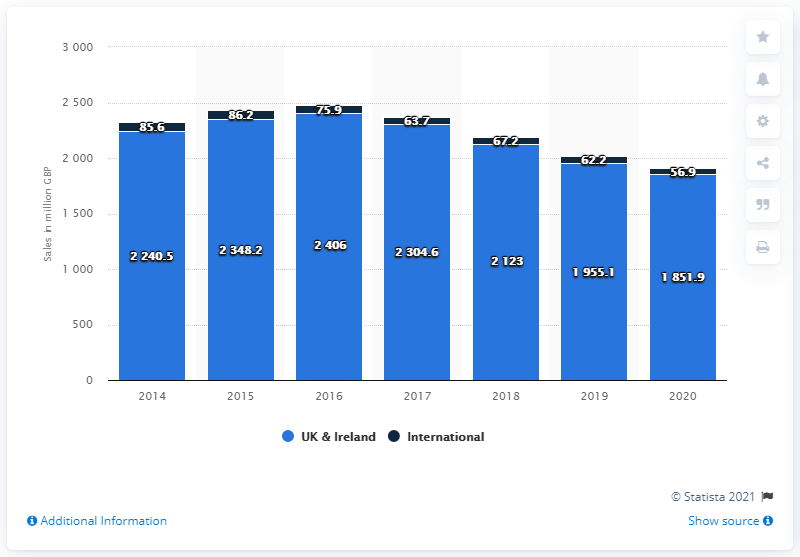What trend can we observe in Next plc's UK and Ireland sales over the past six years? The image shows a bar chart illustrating Next plc's UK and Ireland sales over a span of six years, from 2014 to 2020. There's an initial increase in sales from £2,240.5 million in 2014 to a peak of £2,348.2 million in 2015. Afterward, there is a general downward trend with minor fluctuations, culminating in £1,851.9 million in 2020, which represents the lowest figure in the observed period. 